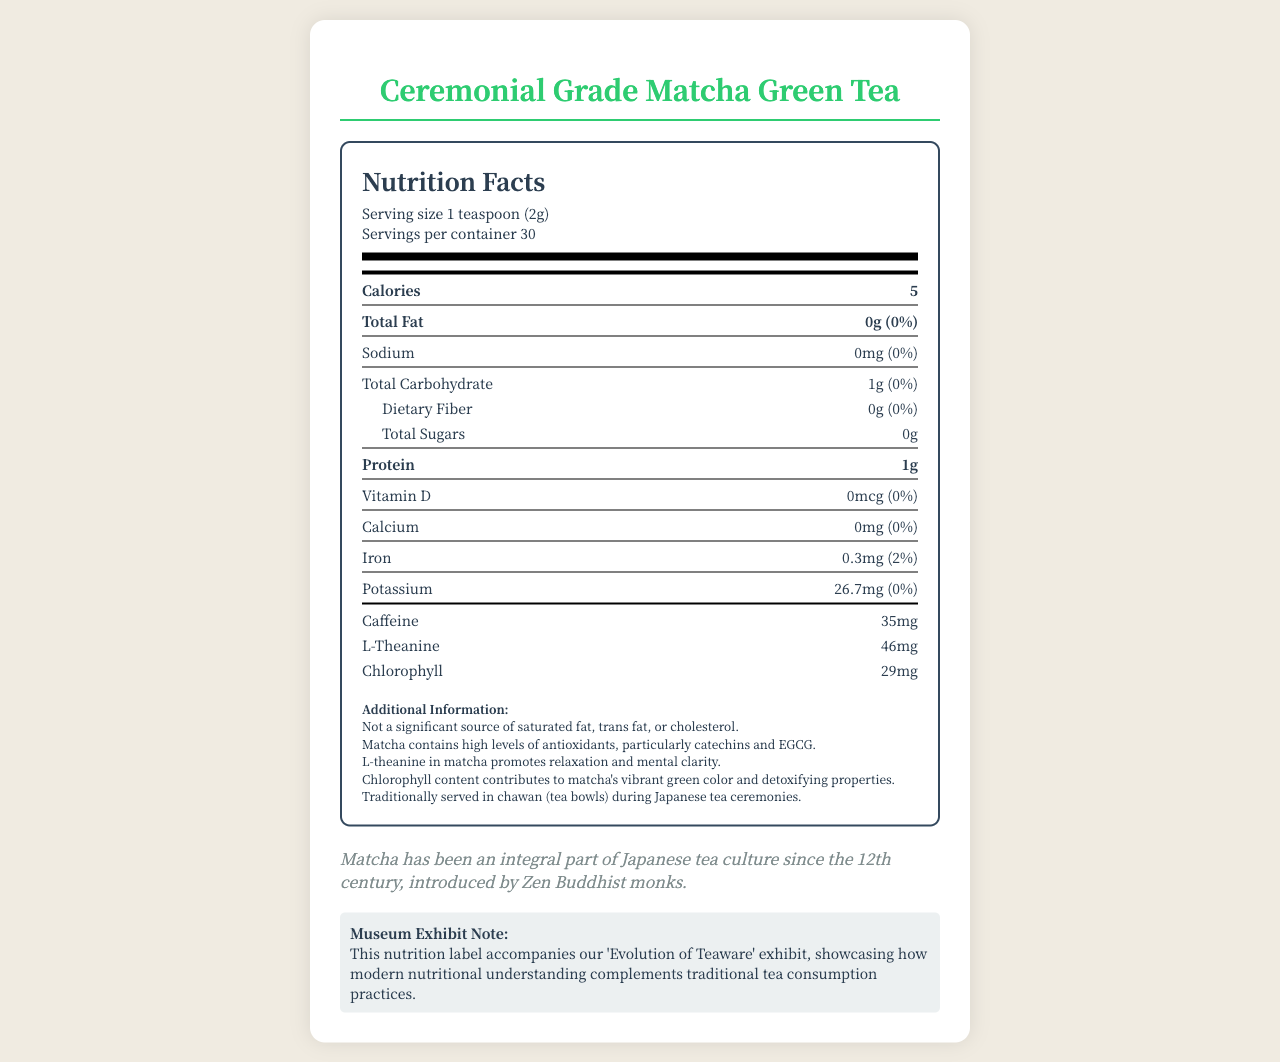what is the serving size of the product? The nutrition label specifies that the serving size for the product is 1 teaspoon (2g).
Answer: 1 teaspoon (2g) how many servings are in the container? The label indicates there are 30 servings per container.
Answer: 30 how many calories are in one serving? The calories per serving are explicitly listed as 5 on the nutrition label.
Answer: 5 how much protein is in one serving of matcha? The label specifies that there is 1g of protein per serving.
Answer: 1g how much iron does one serving provide? The iron content per serving is listed as 0.3mg on the nutrition label.
Answer: 0.3mg what are the total carbohydrates per serving? The label mentions that the total carbohydrates per serving amount to 1g.
Answer: 1g how much caffeine is in a serving of this matcha green tea? The caffeine content per serving is listed as 35mg.
Answer: 35mg how much L-Theanine does one serving contain? The label specifies that one serving contains 46mg of L-Theanine.
Answer: 46mg what is the main ingredient that contributes to the vibrant green color of matcha? The additional information section mentions that chlorophyll contributes to the vibrant green color of matcha.
Answer: Chlorophyll how much sodium is in one serving? The label shows that there is 0mg of sodium per serving.
Answer: 0mg which of the following vitamins is present in matcha? A. Vitamin C B. Vitamin D C. Vitamin A D. Vitamin B12 The nutrition label lists Vitamin D, with an amount of 0mcg and a daily value of 0%, but does not list Vitamin B12.
Answer: B which antioxidant is found in the highest amount per serving? I. Catechins II. Epigallocatechin Gallate III. Carotenoids The label indicates there are 240mg of catechins, 135mg of epigallocatechin gallate, and no mention of carotenoids per serving.
Answer: I does this matcha tea provide a significant source of dietary fiber? The nutrition label lists 0g of dietary fiber per serving.
Answer: No summarize the main nutritional contents and health benefits highlighted in the document. The explanation details the main nutritional elements and health benefits present in the document, including the quantification of specific nutrients and contextual information given in the document.
Answer: The document provides nutrition facts for Ceremonial Grade Matcha Green Tea. Each serving size is 1 teaspoon (2g) with 30 servings per container. Key nutrients per serving include 5 calories, 0g fat, 1g total carbohydrate, and 1g protein. It provides antioxidants (240mg catechins, 135mg epigallocatechin gallate), 35mg caffeine, and 46mg L-Theanine. The additional information highlights the high antioxidant levels, mental clarity benefits from L-theanine, and detoxifying properties from chlorophyll. Historical context notes the integral role of matcha in Japanese tea culture, with the exhibit focusing on merging modern nutritional understanding and traditional tea practices. does this document specify the cholesterol content in matcha? The nutrition label states, "Not a significant source of saturated fat, trans fat, or cholesterol," but does not specify the exact cholesterol content.
Answer: No what is the daily value percentage of iron in one serving? The label indicates that one serving provides 2% of the daily value for iron.
Answer: 2% how much vitamin C is found in this matcha? The label specifies that there is 0mg of vitamin C per serving.
Answer: 0mg which historical context is given about matcha in this document? The historical context provided in the document notes the longstanding significance of matcha in Japanese culture, tracing back to its introduction by Zen Buddhist monks in the 12th century.
Answer: Matcha has been an integral part of Japanese tea culture since the 12th century, introduced by Zen Buddhist monks. 